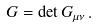Convert formula to latex. <formula><loc_0><loc_0><loc_500><loc_500>G = \det G _ { \mu \nu } \, .</formula> 